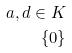Convert formula to latex. <formula><loc_0><loc_0><loc_500><loc_500>a , d \in K \\ \{ 0 \}</formula> 